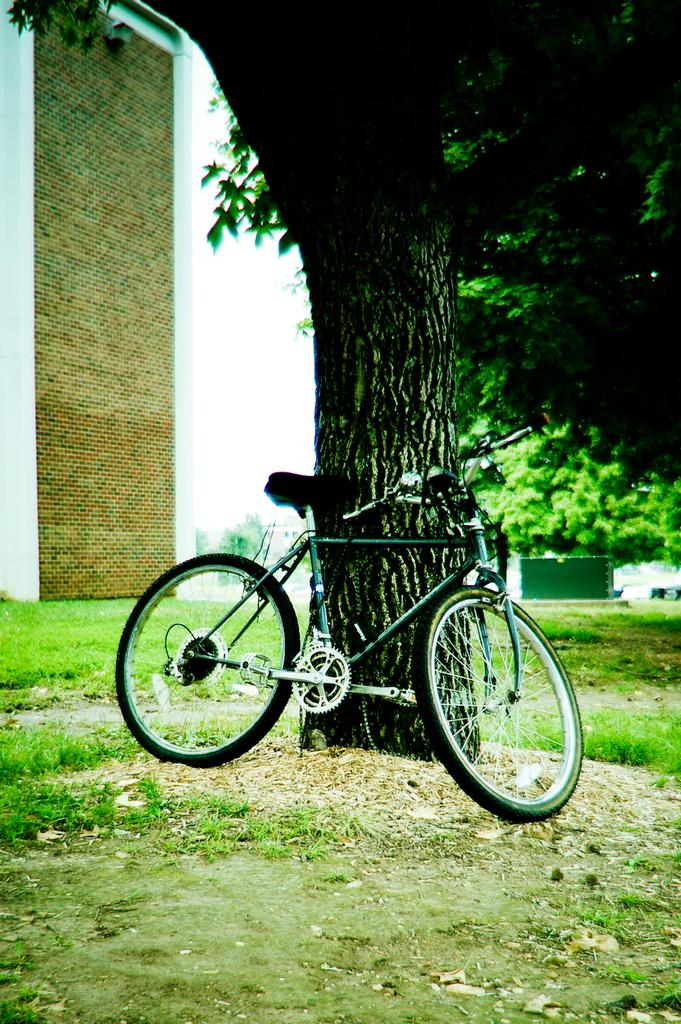What is the main object in the image? There is a bicycle in the image. Where is the bicycle located? The bicycle is on the grass. What can be seen in the background of the image? There are trees, a building, and a shed in the background of the image. What type of eggnog is being served at the meeting in the image? There is no meeting or eggnog present in the image; it features a bicycle on the grass with a background of trees, a building, and a shed. 